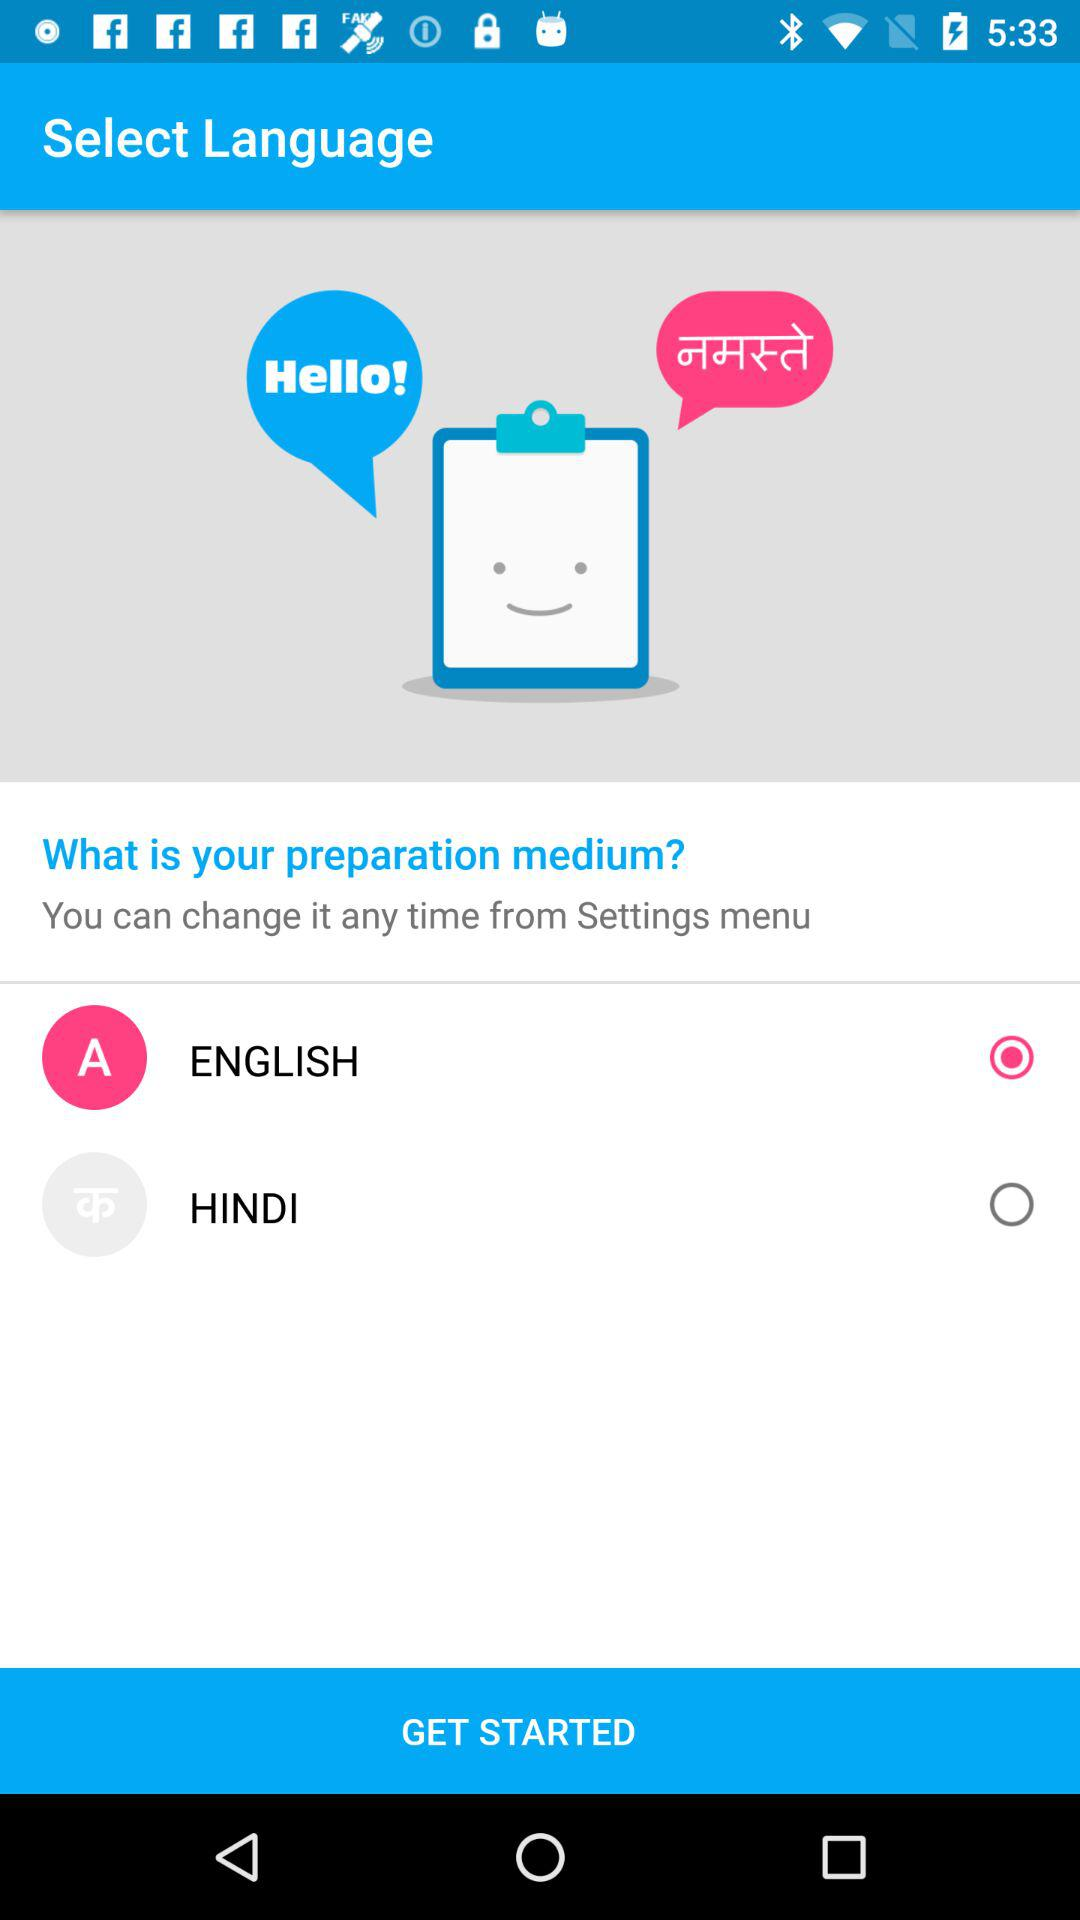How many languages are available on this screen?
Answer the question using a single word or phrase. 2 